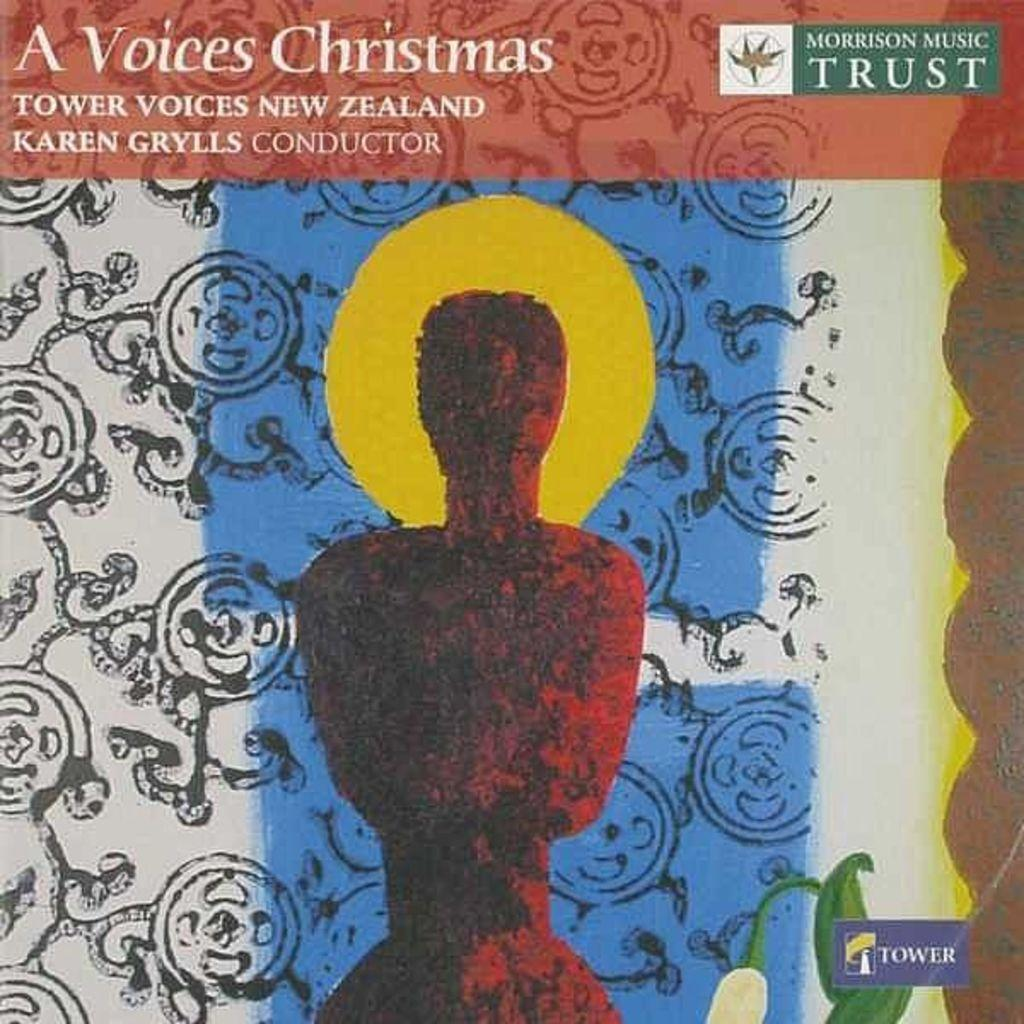What is the main subject of the image? The main subject of the image is an advertisement. Can you describe the advertisement in the image? The advertisement contains some text. What type of reaction can be seen from the animals in the zoo in the image? There is no zoo or animals present in the image; it only contains an advertisement with text. Who is the owner of the advertisement in the image? The concept of an "owner" of an advertisement is not applicable, as advertisements are typically created by companies or organizations, not individuals who can be considered "owners." 